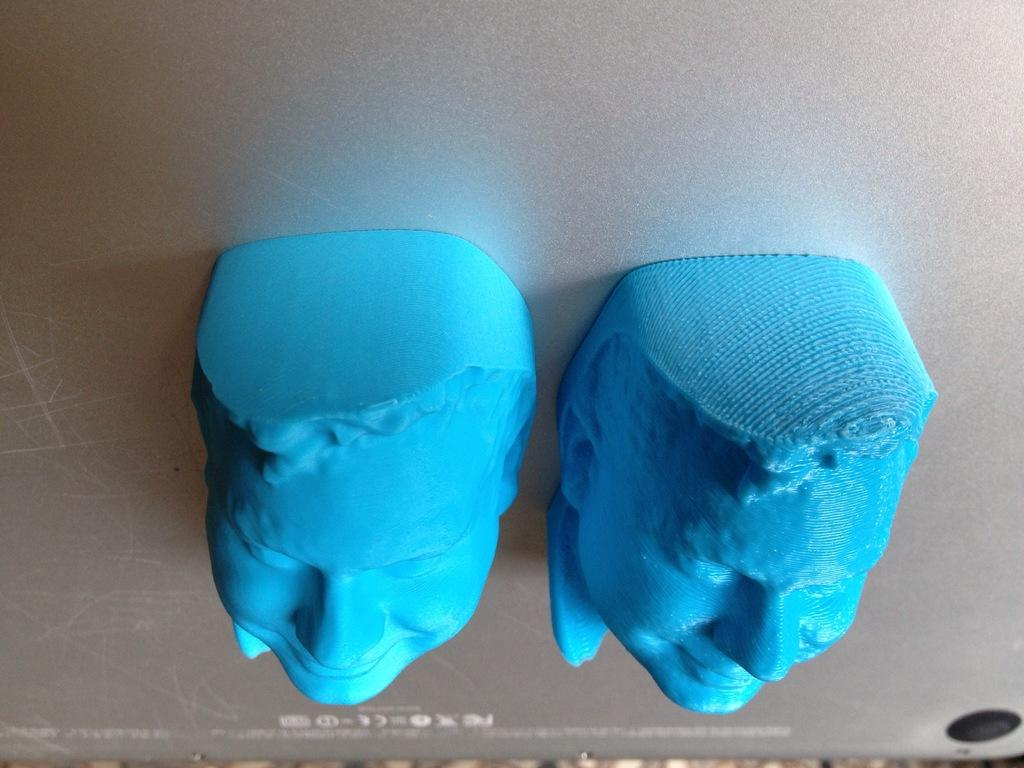What objects are in the foreground of the image? There are two rubber faces in the foreground of the image. Where are the rubber faces located? The rubber faces appear to be on a mobile phone. What type of berry can be seen floating down the river in the image? There is no river or berry present in the image; it features two rubber faces on a mobile phone. 